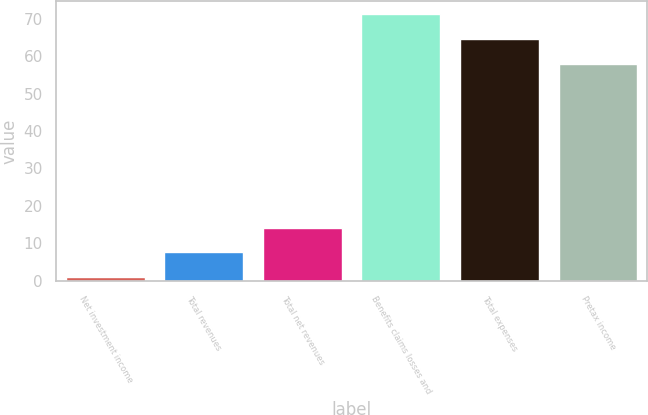<chart> <loc_0><loc_0><loc_500><loc_500><bar_chart><fcel>Net investment income<fcel>Total revenues<fcel>Total net revenues<fcel>Benefits claims losses and<fcel>Total expenses<fcel>Pretax income<nl><fcel>1<fcel>7.6<fcel>14.2<fcel>71.2<fcel>64.6<fcel>58<nl></chart> 